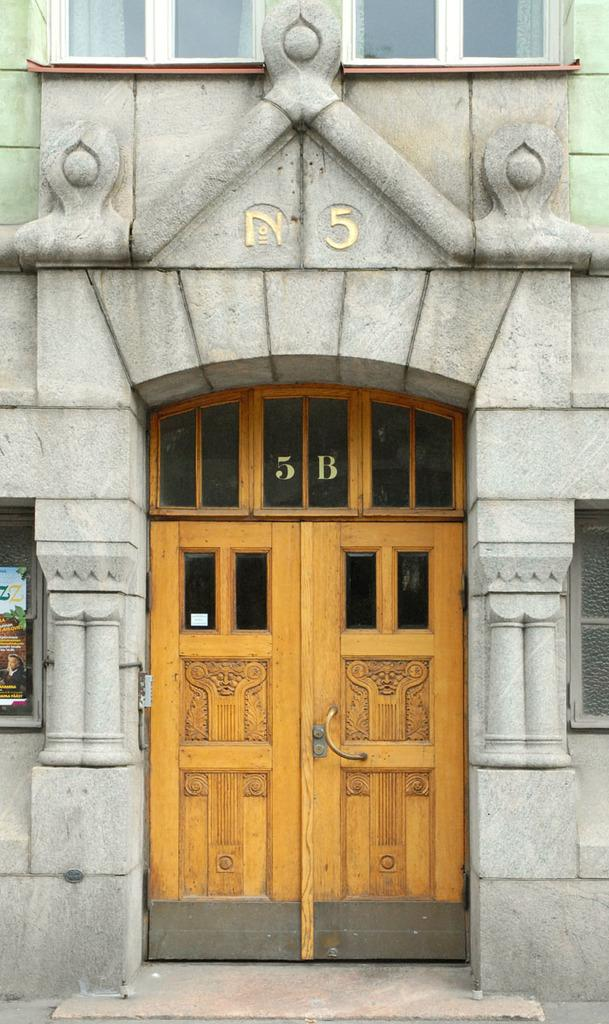What is the main object in the image? There is a door in the image. To which structure does the door belong? The door belongs to a building. Where are the windows located in relation to the door? There are windows on both the right and left sides of the door. Can you describe the sound of people laughing as they swing and jump near the door in the image? There is no mention of people swinging, jumping, or laughing in the image. The image only shows a door with windows on both sides. 